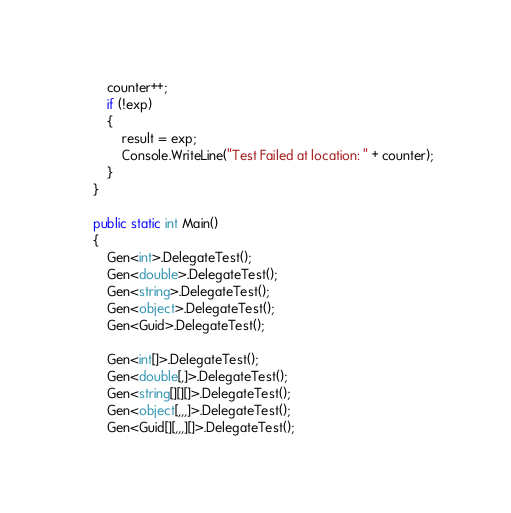Convert code to text. <code><loc_0><loc_0><loc_500><loc_500><_C#_>        counter++;
        if (!exp)
        {
            result = exp;
            Console.WriteLine("Test Failed at location: " + counter);
        }
    }

    public static int Main()
    {
        Gen<int>.DelegateTest();
        Gen<double>.DelegateTest();
        Gen<string>.DelegateTest();
        Gen<object>.DelegateTest();
        Gen<Guid>.DelegateTest();

        Gen<int[]>.DelegateTest();
        Gen<double[,]>.DelegateTest();
        Gen<string[][][]>.DelegateTest();
        Gen<object[,,,]>.DelegateTest();
        Gen<Guid[][,,,][]>.DelegateTest();
</code> 